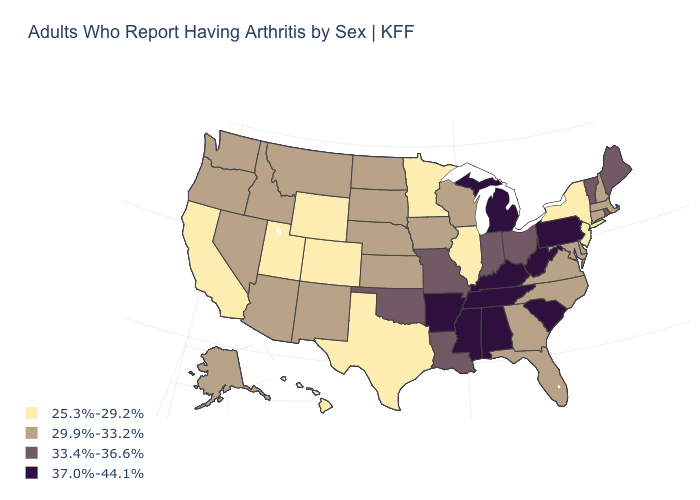What is the highest value in states that border Pennsylvania?
Quick response, please. 37.0%-44.1%. What is the value of Maine?
Concise answer only. 33.4%-36.6%. What is the value of California?
Give a very brief answer. 25.3%-29.2%. Does Kentucky have the same value as Vermont?
Answer briefly. No. How many symbols are there in the legend?
Quick response, please. 4. What is the highest value in the Northeast ?
Answer briefly. 37.0%-44.1%. Does Mississippi have the highest value in the USA?
Keep it brief. Yes. Which states have the highest value in the USA?
Concise answer only. Alabama, Arkansas, Kentucky, Michigan, Mississippi, Pennsylvania, South Carolina, Tennessee, West Virginia. Does the map have missing data?
Answer briefly. No. Among the states that border Kansas , does Colorado have the lowest value?
Quick response, please. Yes. Does South Carolina have a lower value than Arizona?
Write a very short answer. No. Does Kentucky have the highest value in the USA?
Give a very brief answer. Yes. How many symbols are there in the legend?
Answer briefly. 4. What is the value of Rhode Island?
Keep it brief. 33.4%-36.6%. Does Maryland have a higher value than New Jersey?
Concise answer only. Yes. 